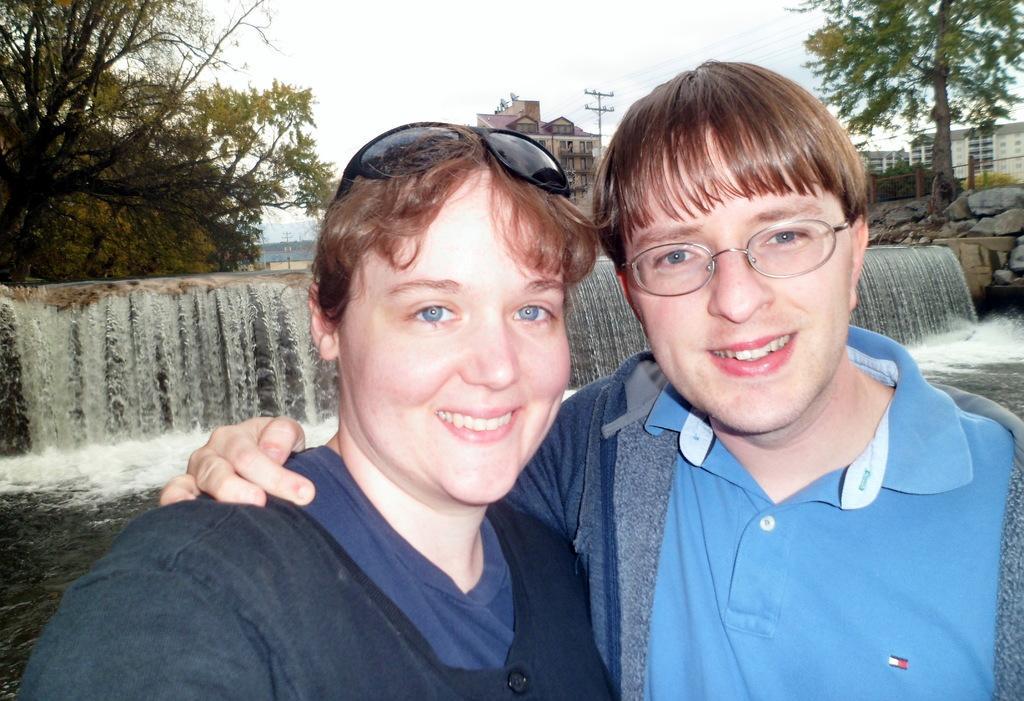Please provide a concise description of this image. In this picture we can see the couple standing in the front, smiling and giving a pose to the camera. Behind we can see the small waterfall and trees. 